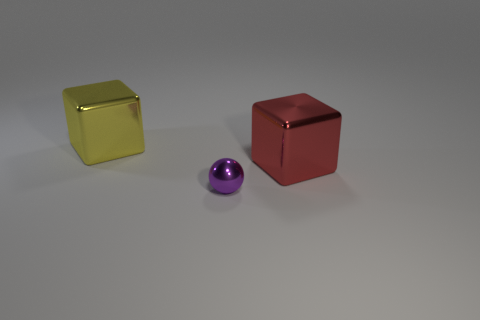Add 1 tiny red metal balls. How many objects exist? 4 Subtract all cubes. How many objects are left? 1 Subtract 0 brown blocks. How many objects are left? 3 Subtract all spheres. Subtract all purple shiny spheres. How many objects are left? 1 Add 3 tiny objects. How many tiny objects are left? 4 Add 3 large metal blocks. How many large metal blocks exist? 5 